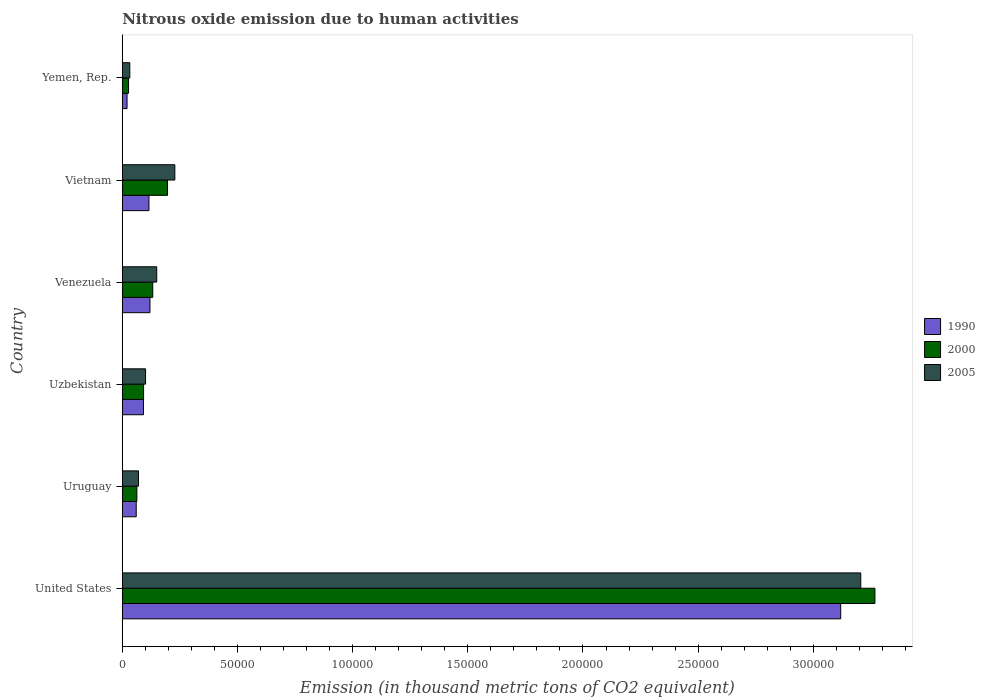How many different coloured bars are there?
Your answer should be compact. 3. How many groups of bars are there?
Keep it short and to the point. 6. Are the number of bars per tick equal to the number of legend labels?
Your response must be concise. Yes. Are the number of bars on each tick of the Y-axis equal?
Your response must be concise. Yes. What is the label of the 4th group of bars from the top?
Your answer should be very brief. Uzbekistan. In how many cases, is the number of bars for a given country not equal to the number of legend labels?
Ensure brevity in your answer.  0. What is the amount of nitrous oxide emitted in 1990 in Uruguay?
Your answer should be compact. 6054.9. Across all countries, what is the maximum amount of nitrous oxide emitted in 1990?
Your answer should be very brief. 3.12e+05. Across all countries, what is the minimum amount of nitrous oxide emitted in 2005?
Give a very brief answer. 3264.5. In which country was the amount of nitrous oxide emitted in 2005 minimum?
Provide a succinct answer. Yemen, Rep. What is the total amount of nitrous oxide emitted in 2005 in the graph?
Make the answer very short. 3.79e+05. What is the difference between the amount of nitrous oxide emitted in 1990 in United States and that in Vietnam?
Your answer should be compact. 3.00e+05. What is the difference between the amount of nitrous oxide emitted in 2000 in Vietnam and the amount of nitrous oxide emitted in 2005 in United States?
Your answer should be compact. -3.01e+05. What is the average amount of nitrous oxide emitted in 1990 per country?
Make the answer very short. 5.88e+04. What is the difference between the amount of nitrous oxide emitted in 2005 and amount of nitrous oxide emitted in 1990 in Uzbekistan?
Your answer should be compact. 913.2. What is the ratio of the amount of nitrous oxide emitted in 1990 in Uruguay to that in Venezuela?
Your answer should be very brief. 0.5. Is the amount of nitrous oxide emitted in 1990 in United States less than that in Vietnam?
Keep it short and to the point. No. What is the difference between the highest and the second highest amount of nitrous oxide emitted in 2000?
Offer a terse response. 3.07e+05. What is the difference between the highest and the lowest amount of nitrous oxide emitted in 2000?
Your answer should be compact. 3.24e+05. Is the sum of the amount of nitrous oxide emitted in 2000 in Uzbekistan and Venezuela greater than the maximum amount of nitrous oxide emitted in 2005 across all countries?
Ensure brevity in your answer.  No. What does the 3rd bar from the bottom in United States represents?
Provide a succinct answer. 2005. Is it the case that in every country, the sum of the amount of nitrous oxide emitted in 2005 and amount of nitrous oxide emitted in 1990 is greater than the amount of nitrous oxide emitted in 2000?
Make the answer very short. Yes. Are all the bars in the graph horizontal?
Give a very brief answer. Yes. How many countries are there in the graph?
Your answer should be very brief. 6. Are the values on the major ticks of X-axis written in scientific E-notation?
Provide a succinct answer. No. Does the graph contain grids?
Make the answer very short. No. How many legend labels are there?
Give a very brief answer. 3. How are the legend labels stacked?
Keep it short and to the point. Vertical. What is the title of the graph?
Your answer should be compact. Nitrous oxide emission due to human activities. Does "2008" appear as one of the legend labels in the graph?
Keep it short and to the point. No. What is the label or title of the X-axis?
Give a very brief answer. Emission (in thousand metric tons of CO2 equivalent). What is the label or title of the Y-axis?
Your answer should be compact. Country. What is the Emission (in thousand metric tons of CO2 equivalent) in 1990 in United States?
Offer a terse response. 3.12e+05. What is the Emission (in thousand metric tons of CO2 equivalent) of 2000 in United States?
Make the answer very short. 3.27e+05. What is the Emission (in thousand metric tons of CO2 equivalent) in 2005 in United States?
Provide a succinct answer. 3.21e+05. What is the Emission (in thousand metric tons of CO2 equivalent) of 1990 in Uruguay?
Offer a terse response. 6054.9. What is the Emission (in thousand metric tons of CO2 equivalent) in 2000 in Uruguay?
Make the answer very short. 6333.8. What is the Emission (in thousand metric tons of CO2 equivalent) in 2005 in Uruguay?
Offer a terse response. 7032.9. What is the Emission (in thousand metric tons of CO2 equivalent) in 1990 in Uzbekistan?
Offer a very short reply. 9195.7. What is the Emission (in thousand metric tons of CO2 equivalent) in 2000 in Uzbekistan?
Ensure brevity in your answer.  9249.1. What is the Emission (in thousand metric tons of CO2 equivalent) of 2005 in Uzbekistan?
Offer a very short reply. 1.01e+04. What is the Emission (in thousand metric tons of CO2 equivalent) of 1990 in Venezuela?
Provide a succinct answer. 1.20e+04. What is the Emission (in thousand metric tons of CO2 equivalent) in 2000 in Venezuela?
Give a very brief answer. 1.32e+04. What is the Emission (in thousand metric tons of CO2 equivalent) in 2005 in Venezuela?
Provide a succinct answer. 1.49e+04. What is the Emission (in thousand metric tons of CO2 equivalent) in 1990 in Vietnam?
Your answer should be compact. 1.16e+04. What is the Emission (in thousand metric tons of CO2 equivalent) in 2000 in Vietnam?
Offer a terse response. 1.96e+04. What is the Emission (in thousand metric tons of CO2 equivalent) of 2005 in Vietnam?
Provide a short and direct response. 2.28e+04. What is the Emission (in thousand metric tons of CO2 equivalent) of 1990 in Yemen, Rep.?
Make the answer very short. 2069.6. What is the Emission (in thousand metric tons of CO2 equivalent) of 2000 in Yemen, Rep.?
Your answer should be compact. 2723.5. What is the Emission (in thousand metric tons of CO2 equivalent) in 2005 in Yemen, Rep.?
Your answer should be compact. 3264.5. Across all countries, what is the maximum Emission (in thousand metric tons of CO2 equivalent) of 1990?
Give a very brief answer. 3.12e+05. Across all countries, what is the maximum Emission (in thousand metric tons of CO2 equivalent) in 2000?
Ensure brevity in your answer.  3.27e+05. Across all countries, what is the maximum Emission (in thousand metric tons of CO2 equivalent) of 2005?
Offer a very short reply. 3.21e+05. Across all countries, what is the minimum Emission (in thousand metric tons of CO2 equivalent) in 1990?
Your response must be concise. 2069.6. Across all countries, what is the minimum Emission (in thousand metric tons of CO2 equivalent) of 2000?
Ensure brevity in your answer.  2723.5. Across all countries, what is the minimum Emission (in thousand metric tons of CO2 equivalent) in 2005?
Keep it short and to the point. 3264.5. What is the total Emission (in thousand metric tons of CO2 equivalent) in 1990 in the graph?
Provide a short and direct response. 3.53e+05. What is the total Emission (in thousand metric tons of CO2 equivalent) in 2000 in the graph?
Keep it short and to the point. 3.78e+05. What is the total Emission (in thousand metric tons of CO2 equivalent) in 2005 in the graph?
Make the answer very short. 3.79e+05. What is the difference between the Emission (in thousand metric tons of CO2 equivalent) in 1990 in United States and that in Uruguay?
Your answer should be compact. 3.06e+05. What is the difference between the Emission (in thousand metric tons of CO2 equivalent) in 2000 in United States and that in Uruguay?
Offer a very short reply. 3.20e+05. What is the difference between the Emission (in thousand metric tons of CO2 equivalent) in 2005 in United States and that in Uruguay?
Offer a very short reply. 3.14e+05. What is the difference between the Emission (in thousand metric tons of CO2 equivalent) of 1990 in United States and that in Uzbekistan?
Ensure brevity in your answer.  3.03e+05. What is the difference between the Emission (in thousand metric tons of CO2 equivalent) of 2000 in United States and that in Uzbekistan?
Provide a succinct answer. 3.17e+05. What is the difference between the Emission (in thousand metric tons of CO2 equivalent) of 2005 in United States and that in Uzbekistan?
Offer a terse response. 3.10e+05. What is the difference between the Emission (in thousand metric tons of CO2 equivalent) in 1990 in United States and that in Venezuela?
Offer a terse response. 3.00e+05. What is the difference between the Emission (in thousand metric tons of CO2 equivalent) of 2000 in United States and that in Venezuela?
Make the answer very short. 3.14e+05. What is the difference between the Emission (in thousand metric tons of CO2 equivalent) of 2005 in United States and that in Venezuela?
Give a very brief answer. 3.06e+05. What is the difference between the Emission (in thousand metric tons of CO2 equivalent) of 1990 in United States and that in Vietnam?
Your answer should be very brief. 3.00e+05. What is the difference between the Emission (in thousand metric tons of CO2 equivalent) of 2000 in United States and that in Vietnam?
Give a very brief answer. 3.07e+05. What is the difference between the Emission (in thousand metric tons of CO2 equivalent) of 2005 in United States and that in Vietnam?
Offer a terse response. 2.98e+05. What is the difference between the Emission (in thousand metric tons of CO2 equivalent) of 1990 in United States and that in Yemen, Rep.?
Your answer should be compact. 3.10e+05. What is the difference between the Emission (in thousand metric tons of CO2 equivalent) of 2000 in United States and that in Yemen, Rep.?
Give a very brief answer. 3.24e+05. What is the difference between the Emission (in thousand metric tons of CO2 equivalent) in 2005 in United States and that in Yemen, Rep.?
Provide a short and direct response. 3.17e+05. What is the difference between the Emission (in thousand metric tons of CO2 equivalent) of 1990 in Uruguay and that in Uzbekistan?
Your response must be concise. -3140.8. What is the difference between the Emission (in thousand metric tons of CO2 equivalent) in 2000 in Uruguay and that in Uzbekistan?
Offer a terse response. -2915.3. What is the difference between the Emission (in thousand metric tons of CO2 equivalent) of 2005 in Uruguay and that in Uzbekistan?
Ensure brevity in your answer.  -3076. What is the difference between the Emission (in thousand metric tons of CO2 equivalent) in 1990 in Uruguay and that in Venezuela?
Give a very brief answer. -5963.1. What is the difference between the Emission (in thousand metric tons of CO2 equivalent) of 2000 in Uruguay and that in Venezuela?
Your answer should be very brief. -6890. What is the difference between the Emission (in thousand metric tons of CO2 equivalent) of 2005 in Uruguay and that in Venezuela?
Your answer should be very brief. -7916.3. What is the difference between the Emission (in thousand metric tons of CO2 equivalent) in 1990 in Uruguay and that in Vietnam?
Provide a short and direct response. -5521.9. What is the difference between the Emission (in thousand metric tons of CO2 equivalent) in 2000 in Uruguay and that in Vietnam?
Your response must be concise. -1.33e+04. What is the difference between the Emission (in thousand metric tons of CO2 equivalent) of 2005 in Uruguay and that in Vietnam?
Your answer should be compact. -1.58e+04. What is the difference between the Emission (in thousand metric tons of CO2 equivalent) of 1990 in Uruguay and that in Yemen, Rep.?
Provide a succinct answer. 3985.3. What is the difference between the Emission (in thousand metric tons of CO2 equivalent) of 2000 in Uruguay and that in Yemen, Rep.?
Your answer should be compact. 3610.3. What is the difference between the Emission (in thousand metric tons of CO2 equivalent) in 2005 in Uruguay and that in Yemen, Rep.?
Provide a succinct answer. 3768.4. What is the difference between the Emission (in thousand metric tons of CO2 equivalent) of 1990 in Uzbekistan and that in Venezuela?
Provide a short and direct response. -2822.3. What is the difference between the Emission (in thousand metric tons of CO2 equivalent) of 2000 in Uzbekistan and that in Venezuela?
Your answer should be compact. -3974.7. What is the difference between the Emission (in thousand metric tons of CO2 equivalent) in 2005 in Uzbekistan and that in Venezuela?
Your response must be concise. -4840.3. What is the difference between the Emission (in thousand metric tons of CO2 equivalent) in 1990 in Uzbekistan and that in Vietnam?
Offer a terse response. -2381.1. What is the difference between the Emission (in thousand metric tons of CO2 equivalent) in 2000 in Uzbekistan and that in Vietnam?
Provide a short and direct response. -1.04e+04. What is the difference between the Emission (in thousand metric tons of CO2 equivalent) of 2005 in Uzbekistan and that in Vietnam?
Give a very brief answer. -1.27e+04. What is the difference between the Emission (in thousand metric tons of CO2 equivalent) of 1990 in Uzbekistan and that in Yemen, Rep.?
Keep it short and to the point. 7126.1. What is the difference between the Emission (in thousand metric tons of CO2 equivalent) of 2000 in Uzbekistan and that in Yemen, Rep.?
Give a very brief answer. 6525.6. What is the difference between the Emission (in thousand metric tons of CO2 equivalent) of 2005 in Uzbekistan and that in Yemen, Rep.?
Your answer should be compact. 6844.4. What is the difference between the Emission (in thousand metric tons of CO2 equivalent) of 1990 in Venezuela and that in Vietnam?
Your response must be concise. 441.2. What is the difference between the Emission (in thousand metric tons of CO2 equivalent) of 2000 in Venezuela and that in Vietnam?
Ensure brevity in your answer.  -6403.5. What is the difference between the Emission (in thousand metric tons of CO2 equivalent) in 2005 in Venezuela and that in Vietnam?
Your response must be concise. -7864.9. What is the difference between the Emission (in thousand metric tons of CO2 equivalent) in 1990 in Venezuela and that in Yemen, Rep.?
Offer a very short reply. 9948.4. What is the difference between the Emission (in thousand metric tons of CO2 equivalent) of 2000 in Venezuela and that in Yemen, Rep.?
Offer a terse response. 1.05e+04. What is the difference between the Emission (in thousand metric tons of CO2 equivalent) of 2005 in Venezuela and that in Yemen, Rep.?
Make the answer very short. 1.17e+04. What is the difference between the Emission (in thousand metric tons of CO2 equivalent) of 1990 in Vietnam and that in Yemen, Rep.?
Your response must be concise. 9507.2. What is the difference between the Emission (in thousand metric tons of CO2 equivalent) in 2000 in Vietnam and that in Yemen, Rep.?
Make the answer very short. 1.69e+04. What is the difference between the Emission (in thousand metric tons of CO2 equivalent) in 2005 in Vietnam and that in Yemen, Rep.?
Your response must be concise. 1.95e+04. What is the difference between the Emission (in thousand metric tons of CO2 equivalent) in 1990 in United States and the Emission (in thousand metric tons of CO2 equivalent) in 2000 in Uruguay?
Provide a succinct answer. 3.06e+05. What is the difference between the Emission (in thousand metric tons of CO2 equivalent) in 1990 in United States and the Emission (in thousand metric tons of CO2 equivalent) in 2005 in Uruguay?
Provide a succinct answer. 3.05e+05. What is the difference between the Emission (in thousand metric tons of CO2 equivalent) of 2000 in United States and the Emission (in thousand metric tons of CO2 equivalent) of 2005 in Uruguay?
Ensure brevity in your answer.  3.20e+05. What is the difference between the Emission (in thousand metric tons of CO2 equivalent) of 1990 in United States and the Emission (in thousand metric tons of CO2 equivalent) of 2000 in Uzbekistan?
Make the answer very short. 3.03e+05. What is the difference between the Emission (in thousand metric tons of CO2 equivalent) of 1990 in United States and the Emission (in thousand metric tons of CO2 equivalent) of 2005 in Uzbekistan?
Your answer should be very brief. 3.02e+05. What is the difference between the Emission (in thousand metric tons of CO2 equivalent) in 2000 in United States and the Emission (in thousand metric tons of CO2 equivalent) in 2005 in Uzbekistan?
Give a very brief answer. 3.17e+05. What is the difference between the Emission (in thousand metric tons of CO2 equivalent) in 1990 in United States and the Emission (in thousand metric tons of CO2 equivalent) in 2000 in Venezuela?
Make the answer very short. 2.99e+05. What is the difference between the Emission (in thousand metric tons of CO2 equivalent) in 1990 in United States and the Emission (in thousand metric tons of CO2 equivalent) in 2005 in Venezuela?
Offer a terse response. 2.97e+05. What is the difference between the Emission (in thousand metric tons of CO2 equivalent) of 2000 in United States and the Emission (in thousand metric tons of CO2 equivalent) of 2005 in Venezuela?
Offer a very short reply. 3.12e+05. What is the difference between the Emission (in thousand metric tons of CO2 equivalent) of 1990 in United States and the Emission (in thousand metric tons of CO2 equivalent) of 2000 in Vietnam?
Provide a short and direct response. 2.92e+05. What is the difference between the Emission (in thousand metric tons of CO2 equivalent) in 1990 in United States and the Emission (in thousand metric tons of CO2 equivalent) in 2005 in Vietnam?
Make the answer very short. 2.89e+05. What is the difference between the Emission (in thousand metric tons of CO2 equivalent) in 2000 in United States and the Emission (in thousand metric tons of CO2 equivalent) in 2005 in Vietnam?
Offer a very short reply. 3.04e+05. What is the difference between the Emission (in thousand metric tons of CO2 equivalent) of 1990 in United States and the Emission (in thousand metric tons of CO2 equivalent) of 2000 in Yemen, Rep.?
Provide a succinct answer. 3.09e+05. What is the difference between the Emission (in thousand metric tons of CO2 equivalent) in 1990 in United States and the Emission (in thousand metric tons of CO2 equivalent) in 2005 in Yemen, Rep.?
Keep it short and to the point. 3.09e+05. What is the difference between the Emission (in thousand metric tons of CO2 equivalent) in 2000 in United States and the Emission (in thousand metric tons of CO2 equivalent) in 2005 in Yemen, Rep.?
Offer a terse response. 3.23e+05. What is the difference between the Emission (in thousand metric tons of CO2 equivalent) of 1990 in Uruguay and the Emission (in thousand metric tons of CO2 equivalent) of 2000 in Uzbekistan?
Give a very brief answer. -3194.2. What is the difference between the Emission (in thousand metric tons of CO2 equivalent) in 1990 in Uruguay and the Emission (in thousand metric tons of CO2 equivalent) in 2005 in Uzbekistan?
Offer a terse response. -4054. What is the difference between the Emission (in thousand metric tons of CO2 equivalent) of 2000 in Uruguay and the Emission (in thousand metric tons of CO2 equivalent) of 2005 in Uzbekistan?
Keep it short and to the point. -3775.1. What is the difference between the Emission (in thousand metric tons of CO2 equivalent) in 1990 in Uruguay and the Emission (in thousand metric tons of CO2 equivalent) in 2000 in Venezuela?
Provide a succinct answer. -7168.9. What is the difference between the Emission (in thousand metric tons of CO2 equivalent) in 1990 in Uruguay and the Emission (in thousand metric tons of CO2 equivalent) in 2005 in Venezuela?
Provide a succinct answer. -8894.3. What is the difference between the Emission (in thousand metric tons of CO2 equivalent) of 2000 in Uruguay and the Emission (in thousand metric tons of CO2 equivalent) of 2005 in Venezuela?
Ensure brevity in your answer.  -8615.4. What is the difference between the Emission (in thousand metric tons of CO2 equivalent) of 1990 in Uruguay and the Emission (in thousand metric tons of CO2 equivalent) of 2000 in Vietnam?
Ensure brevity in your answer.  -1.36e+04. What is the difference between the Emission (in thousand metric tons of CO2 equivalent) of 1990 in Uruguay and the Emission (in thousand metric tons of CO2 equivalent) of 2005 in Vietnam?
Keep it short and to the point. -1.68e+04. What is the difference between the Emission (in thousand metric tons of CO2 equivalent) of 2000 in Uruguay and the Emission (in thousand metric tons of CO2 equivalent) of 2005 in Vietnam?
Your answer should be compact. -1.65e+04. What is the difference between the Emission (in thousand metric tons of CO2 equivalent) of 1990 in Uruguay and the Emission (in thousand metric tons of CO2 equivalent) of 2000 in Yemen, Rep.?
Provide a succinct answer. 3331.4. What is the difference between the Emission (in thousand metric tons of CO2 equivalent) of 1990 in Uruguay and the Emission (in thousand metric tons of CO2 equivalent) of 2005 in Yemen, Rep.?
Your answer should be very brief. 2790.4. What is the difference between the Emission (in thousand metric tons of CO2 equivalent) of 2000 in Uruguay and the Emission (in thousand metric tons of CO2 equivalent) of 2005 in Yemen, Rep.?
Ensure brevity in your answer.  3069.3. What is the difference between the Emission (in thousand metric tons of CO2 equivalent) of 1990 in Uzbekistan and the Emission (in thousand metric tons of CO2 equivalent) of 2000 in Venezuela?
Ensure brevity in your answer.  -4028.1. What is the difference between the Emission (in thousand metric tons of CO2 equivalent) in 1990 in Uzbekistan and the Emission (in thousand metric tons of CO2 equivalent) in 2005 in Venezuela?
Provide a succinct answer. -5753.5. What is the difference between the Emission (in thousand metric tons of CO2 equivalent) in 2000 in Uzbekistan and the Emission (in thousand metric tons of CO2 equivalent) in 2005 in Venezuela?
Keep it short and to the point. -5700.1. What is the difference between the Emission (in thousand metric tons of CO2 equivalent) in 1990 in Uzbekistan and the Emission (in thousand metric tons of CO2 equivalent) in 2000 in Vietnam?
Offer a terse response. -1.04e+04. What is the difference between the Emission (in thousand metric tons of CO2 equivalent) in 1990 in Uzbekistan and the Emission (in thousand metric tons of CO2 equivalent) in 2005 in Vietnam?
Ensure brevity in your answer.  -1.36e+04. What is the difference between the Emission (in thousand metric tons of CO2 equivalent) of 2000 in Uzbekistan and the Emission (in thousand metric tons of CO2 equivalent) of 2005 in Vietnam?
Provide a short and direct response. -1.36e+04. What is the difference between the Emission (in thousand metric tons of CO2 equivalent) in 1990 in Uzbekistan and the Emission (in thousand metric tons of CO2 equivalent) in 2000 in Yemen, Rep.?
Offer a very short reply. 6472.2. What is the difference between the Emission (in thousand metric tons of CO2 equivalent) of 1990 in Uzbekistan and the Emission (in thousand metric tons of CO2 equivalent) of 2005 in Yemen, Rep.?
Your response must be concise. 5931.2. What is the difference between the Emission (in thousand metric tons of CO2 equivalent) in 2000 in Uzbekistan and the Emission (in thousand metric tons of CO2 equivalent) in 2005 in Yemen, Rep.?
Keep it short and to the point. 5984.6. What is the difference between the Emission (in thousand metric tons of CO2 equivalent) of 1990 in Venezuela and the Emission (in thousand metric tons of CO2 equivalent) of 2000 in Vietnam?
Give a very brief answer. -7609.3. What is the difference between the Emission (in thousand metric tons of CO2 equivalent) of 1990 in Venezuela and the Emission (in thousand metric tons of CO2 equivalent) of 2005 in Vietnam?
Provide a succinct answer. -1.08e+04. What is the difference between the Emission (in thousand metric tons of CO2 equivalent) in 2000 in Venezuela and the Emission (in thousand metric tons of CO2 equivalent) in 2005 in Vietnam?
Make the answer very short. -9590.3. What is the difference between the Emission (in thousand metric tons of CO2 equivalent) in 1990 in Venezuela and the Emission (in thousand metric tons of CO2 equivalent) in 2000 in Yemen, Rep.?
Provide a short and direct response. 9294.5. What is the difference between the Emission (in thousand metric tons of CO2 equivalent) in 1990 in Venezuela and the Emission (in thousand metric tons of CO2 equivalent) in 2005 in Yemen, Rep.?
Give a very brief answer. 8753.5. What is the difference between the Emission (in thousand metric tons of CO2 equivalent) of 2000 in Venezuela and the Emission (in thousand metric tons of CO2 equivalent) of 2005 in Yemen, Rep.?
Provide a short and direct response. 9959.3. What is the difference between the Emission (in thousand metric tons of CO2 equivalent) of 1990 in Vietnam and the Emission (in thousand metric tons of CO2 equivalent) of 2000 in Yemen, Rep.?
Your answer should be compact. 8853.3. What is the difference between the Emission (in thousand metric tons of CO2 equivalent) in 1990 in Vietnam and the Emission (in thousand metric tons of CO2 equivalent) in 2005 in Yemen, Rep.?
Make the answer very short. 8312.3. What is the difference between the Emission (in thousand metric tons of CO2 equivalent) in 2000 in Vietnam and the Emission (in thousand metric tons of CO2 equivalent) in 2005 in Yemen, Rep.?
Offer a very short reply. 1.64e+04. What is the average Emission (in thousand metric tons of CO2 equivalent) of 1990 per country?
Provide a short and direct response. 5.88e+04. What is the average Emission (in thousand metric tons of CO2 equivalent) in 2000 per country?
Ensure brevity in your answer.  6.30e+04. What is the average Emission (in thousand metric tons of CO2 equivalent) of 2005 per country?
Give a very brief answer. 6.31e+04. What is the difference between the Emission (in thousand metric tons of CO2 equivalent) in 1990 and Emission (in thousand metric tons of CO2 equivalent) in 2000 in United States?
Your answer should be compact. -1.49e+04. What is the difference between the Emission (in thousand metric tons of CO2 equivalent) in 1990 and Emission (in thousand metric tons of CO2 equivalent) in 2005 in United States?
Provide a short and direct response. -8707.9. What is the difference between the Emission (in thousand metric tons of CO2 equivalent) of 2000 and Emission (in thousand metric tons of CO2 equivalent) of 2005 in United States?
Your answer should be very brief. 6144.9. What is the difference between the Emission (in thousand metric tons of CO2 equivalent) of 1990 and Emission (in thousand metric tons of CO2 equivalent) of 2000 in Uruguay?
Provide a succinct answer. -278.9. What is the difference between the Emission (in thousand metric tons of CO2 equivalent) in 1990 and Emission (in thousand metric tons of CO2 equivalent) in 2005 in Uruguay?
Offer a very short reply. -978. What is the difference between the Emission (in thousand metric tons of CO2 equivalent) of 2000 and Emission (in thousand metric tons of CO2 equivalent) of 2005 in Uruguay?
Keep it short and to the point. -699.1. What is the difference between the Emission (in thousand metric tons of CO2 equivalent) of 1990 and Emission (in thousand metric tons of CO2 equivalent) of 2000 in Uzbekistan?
Your response must be concise. -53.4. What is the difference between the Emission (in thousand metric tons of CO2 equivalent) in 1990 and Emission (in thousand metric tons of CO2 equivalent) in 2005 in Uzbekistan?
Offer a very short reply. -913.2. What is the difference between the Emission (in thousand metric tons of CO2 equivalent) of 2000 and Emission (in thousand metric tons of CO2 equivalent) of 2005 in Uzbekistan?
Your answer should be very brief. -859.8. What is the difference between the Emission (in thousand metric tons of CO2 equivalent) of 1990 and Emission (in thousand metric tons of CO2 equivalent) of 2000 in Venezuela?
Your answer should be compact. -1205.8. What is the difference between the Emission (in thousand metric tons of CO2 equivalent) in 1990 and Emission (in thousand metric tons of CO2 equivalent) in 2005 in Venezuela?
Ensure brevity in your answer.  -2931.2. What is the difference between the Emission (in thousand metric tons of CO2 equivalent) in 2000 and Emission (in thousand metric tons of CO2 equivalent) in 2005 in Venezuela?
Your response must be concise. -1725.4. What is the difference between the Emission (in thousand metric tons of CO2 equivalent) in 1990 and Emission (in thousand metric tons of CO2 equivalent) in 2000 in Vietnam?
Your answer should be compact. -8050.5. What is the difference between the Emission (in thousand metric tons of CO2 equivalent) of 1990 and Emission (in thousand metric tons of CO2 equivalent) of 2005 in Vietnam?
Give a very brief answer. -1.12e+04. What is the difference between the Emission (in thousand metric tons of CO2 equivalent) in 2000 and Emission (in thousand metric tons of CO2 equivalent) in 2005 in Vietnam?
Offer a terse response. -3186.8. What is the difference between the Emission (in thousand metric tons of CO2 equivalent) in 1990 and Emission (in thousand metric tons of CO2 equivalent) in 2000 in Yemen, Rep.?
Provide a short and direct response. -653.9. What is the difference between the Emission (in thousand metric tons of CO2 equivalent) of 1990 and Emission (in thousand metric tons of CO2 equivalent) of 2005 in Yemen, Rep.?
Your response must be concise. -1194.9. What is the difference between the Emission (in thousand metric tons of CO2 equivalent) of 2000 and Emission (in thousand metric tons of CO2 equivalent) of 2005 in Yemen, Rep.?
Keep it short and to the point. -541. What is the ratio of the Emission (in thousand metric tons of CO2 equivalent) of 1990 in United States to that in Uruguay?
Your answer should be compact. 51.51. What is the ratio of the Emission (in thousand metric tons of CO2 equivalent) of 2000 in United States to that in Uruguay?
Provide a succinct answer. 51.59. What is the ratio of the Emission (in thousand metric tons of CO2 equivalent) of 2005 in United States to that in Uruguay?
Your answer should be very brief. 45.59. What is the ratio of the Emission (in thousand metric tons of CO2 equivalent) in 1990 in United States to that in Uzbekistan?
Give a very brief answer. 33.92. What is the ratio of the Emission (in thousand metric tons of CO2 equivalent) of 2000 in United States to that in Uzbekistan?
Offer a very short reply. 35.33. What is the ratio of the Emission (in thousand metric tons of CO2 equivalent) of 2005 in United States to that in Uzbekistan?
Provide a short and direct response. 31.71. What is the ratio of the Emission (in thousand metric tons of CO2 equivalent) of 1990 in United States to that in Venezuela?
Keep it short and to the point. 25.95. What is the ratio of the Emission (in thousand metric tons of CO2 equivalent) of 2000 in United States to that in Venezuela?
Provide a short and direct response. 24.71. What is the ratio of the Emission (in thousand metric tons of CO2 equivalent) of 2005 in United States to that in Venezuela?
Offer a very short reply. 21.45. What is the ratio of the Emission (in thousand metric tons of CO2 equivalent) of 1990 in United States to that in Vietnam?
Your answer should be very brief. 26.94. What is the ratio of the Emission (in thousand metric tons of CO2 equivalent) of 2000 in United States to that in Vietnam?
Keep it short and to the point. 16.65. What is the ratio of the Emission (in thousand metric tons of CO2 equivalent) in 2005 in United States to that in Vietnam?
Your response must be concise. 14.05. What is the ratio of the Emission (in thousand metric tons of CO2 equivalent) in 1990 in United States to that in Yemen, Rep.?
Your answer should be compact. 150.7. What is the ratio of the Emission (in thousand metric tons of CO2 equivalent) in 2000 in United States to that in Yemen, Rep.?
Provide a succinct answer. 119.97. What is the ratio of the Emission (in thousand metric tons of CO2 equivalent) in 2005 in United States to that in Yemen, Rep.?
Your response must be concise. 98.21. What is the ratio of the Emission (in thousand metric tons of CO2 equivalent) in 1990 in Uruguay to that in Uzbekistan?
Your response must be concise. 0.66. What is the ratio of the Emission (in thousand metric tons of CO2 equivalent) in 2000 in Uruguay to that in Uzbekistan?
Keep it short and to the point. 0.68. What is the ratio of the Emission (in thousand metric tons of CO2 equivalent) of 2005 in Uruguay to that in Uzbekistan?
Provide a short and direct response. 0.7. What is the ratio of the Emission (in thousand metric tons of CO2 equivalent) in 1990 in Uruguay to that in Venezuela?
Make the answer very short. 0.5. What is the ratio of the Emission (in thousand metric tons of CO2 equivalent) of 2000 in Uruguay to that in Venezuela?
Your response must be concise. 0.48. What is the ratio of the Emission (in thousand metric tons of CO2 equivalent) of 2005 in Uruguay to that in Venezuela?
Give a very brief answer. 0.47. What is the ratio of the Emission (in thousand metric tons of CO2 equivalent) in 1990 in Uruguay to that in Vietnam?
Make the answer very short. 0.52. What is the ratio of the Emission (in thousand metric tons of CO2 equivalent) of 2000 in Uruguay to that in Vietnam?
Offer a terse response. 0.32. What is the ratio of the Emission (in thousand metric tons of CO2 equivalent) of 2005 in Uruguay to that in Vietnam?
Offer a very short reply. 0.31. What is the ratio of the Emission (in thousand metric tons of CO2 equivalent) in 1990 in Uruguay to that in Yemen, Rep.?
Provide a succinct answer. 2.93. What is the ratio of the Emission (in thousand metric tons of CO2 equivalent) of 2000 in Uruguay to that in Yemen, Rep.?
Make the answer very short. 2.33. What is the ratio of the Emission (in thousand metric tons of CO2 equivalent) of 2005 in Uruguay to that in Yemen, Rep.?
Ensure brevity in your answer.  2.15. What is the ratio of the Emission (in thousand metric tons of CO2 equivalent) of 1990 in Uzbekistan to that in Venezuela?
Your response must be concise. 0.77. What is the ratio of the Emission (in thousand metric tons of CO2 equivalent) of 2000 in Uzbekistan to that in Venezuela?
Make the answer very short. 0.7. What is the ratio of the Emission (in thousand metric tons of CO2 equivalent) of 2005 in Uzbekistan to that in Venezuela?
Ensure brevity in your answer.  0.68. What is the ratio of the Emission (in thousand metric tons of CO2 equivalent) in 1990 in Uzbekistan to that in Vietnam?
Your answer should be compact. 0.79. What is the ratio of the Emission (in thousand metric tons of CO2 equivalent) of 2000 in Uzbekistan to that in Vietnam?
Offer a terse response. 0.47. What is the ratio of the Emission (in thousand metric tons of CO2 equivalent) in 2005 in Uzbekistan to that in Vietnam?
Provide a short and direct response. 0.44. What is the ratio of the Emission (in thousand metric tons of CO2 equivalent) of 1990 in Uzbekistan to that in Yemen, Rep.?
Your answer should be compact. 4.44. What is the ratio of the Emission (in thousand metric tons of CO2 equivalent) of 2000 in Uzbekistan to that in Yemen, Rep.?
Make the answer very short. 3.4. What is the ratio of the Emission (in thousand metric tons of CO2 equivalent) of 2005 in Uzbekistan to that in Yemen, Rep.?
Your answer should be compact. 3.1. What is the ratio of the Emission (in thousand metric tons of CO2 equivalent) of 1990 in Venezuela to that in Vietnam?
Keep it short and to the point. 1.04. What is the ratio of the Emission (in thousand metric tons of CO2 equivalent) of 2000 in Venezuela to that in Vietnam?
Your response must be concise. 0.67. What is the ratio of the Emission (in thousand metric tons of CO2 equivalent) in 2005 in Venezuela to that in Vietnam?
Offer a terse response. 0.66. What is the ratio of the Emission (in thousand metric tons of CO2 equivalent) of 1990 in Venezuela to that in Yemen, Rep.?
Make the answer very short. 5.81. What is the ratio of the Emission (in thousand metric tons of CO2 equivalent) in 2000 in Venezuela to that in Yemen, Rep.?
Offer a very short reply. 4.86. What is the ratio of the Emission (in thousand metric tons of CO2 equivalent) in 2005 in Venezuela to that in Yemen, Rep.?
Keep it short and to the point. 4.58. What is the ratio of the Emission (in thousand metric tons of CO2 equivalent) in 1990 in Vietnam to that in Yemen, Rep.?
Provide a succinct answer. 5.59. What is the ratio of the Emission (in thousand metric tons of CO2 equivalent) of 2000 in Vietnam to that in Yemen, Rep.?
Provide a succinct answer. 7.21. What is the ratio of the Emission (in thousand metric tons of CO2 equivalent) of 2005 in Vietnam to that in Yemen, Rep.?
Provide a short and direct response. 6.99. What is the difference between the highest and the second highest Emission (in thousand metric tons of CO2 equivalent) in 1990?
Provide a short and direct response. 3.00e+05. What is the difference between the highest and the second highest Emission (in thousand metric tons of CO2 equivalent) of 2000?
Make the answer very short. 3.07e+05. What is the difference between the highest and the second highest Emission (in thousand metric tons of CO2 equivalent) of 2005?
Provide a succinct answer. 2.98e+05. What is the difference between the highest and the lowest Emission (in thousand metric tons of CO2 equivalent) in 1990?
Offer a terse response. 3.10e+05. What is the difference between the highest and the lowest Emission (in thousand metric tons of CO2 equivalent) of 2000?
Give a very brief answer. 3.24e+05. What is the difference between the highest and the lowest Emission (in thousand metric tons of CO2 equivalent) in 2005?
Your answer should be very brief. 3.17e+05. 